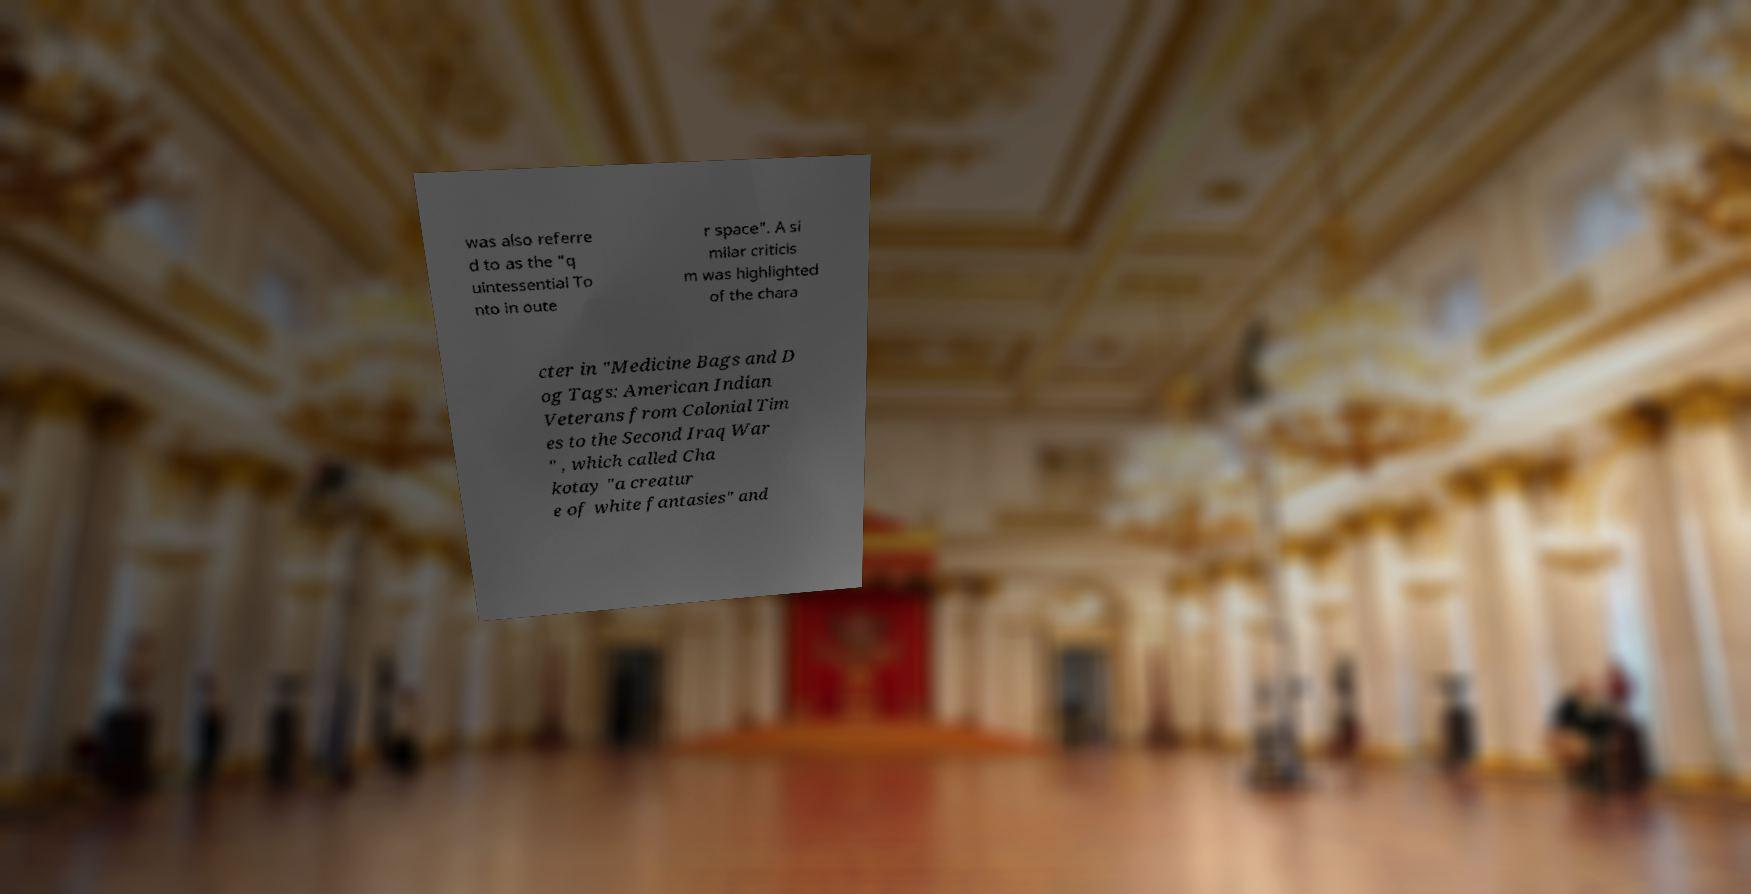Could you extract and type out the text from this image? was also referre d to as the "q uintessential To nto in oute r space". A si milar criticis m was highlighted of the chara cter in "Medicine Bags and D og Tags: American Indian Veterans from Colonial Tim es to the Second Iraq War " , which called Cha kotay "a creatur e of white fantasies" and 